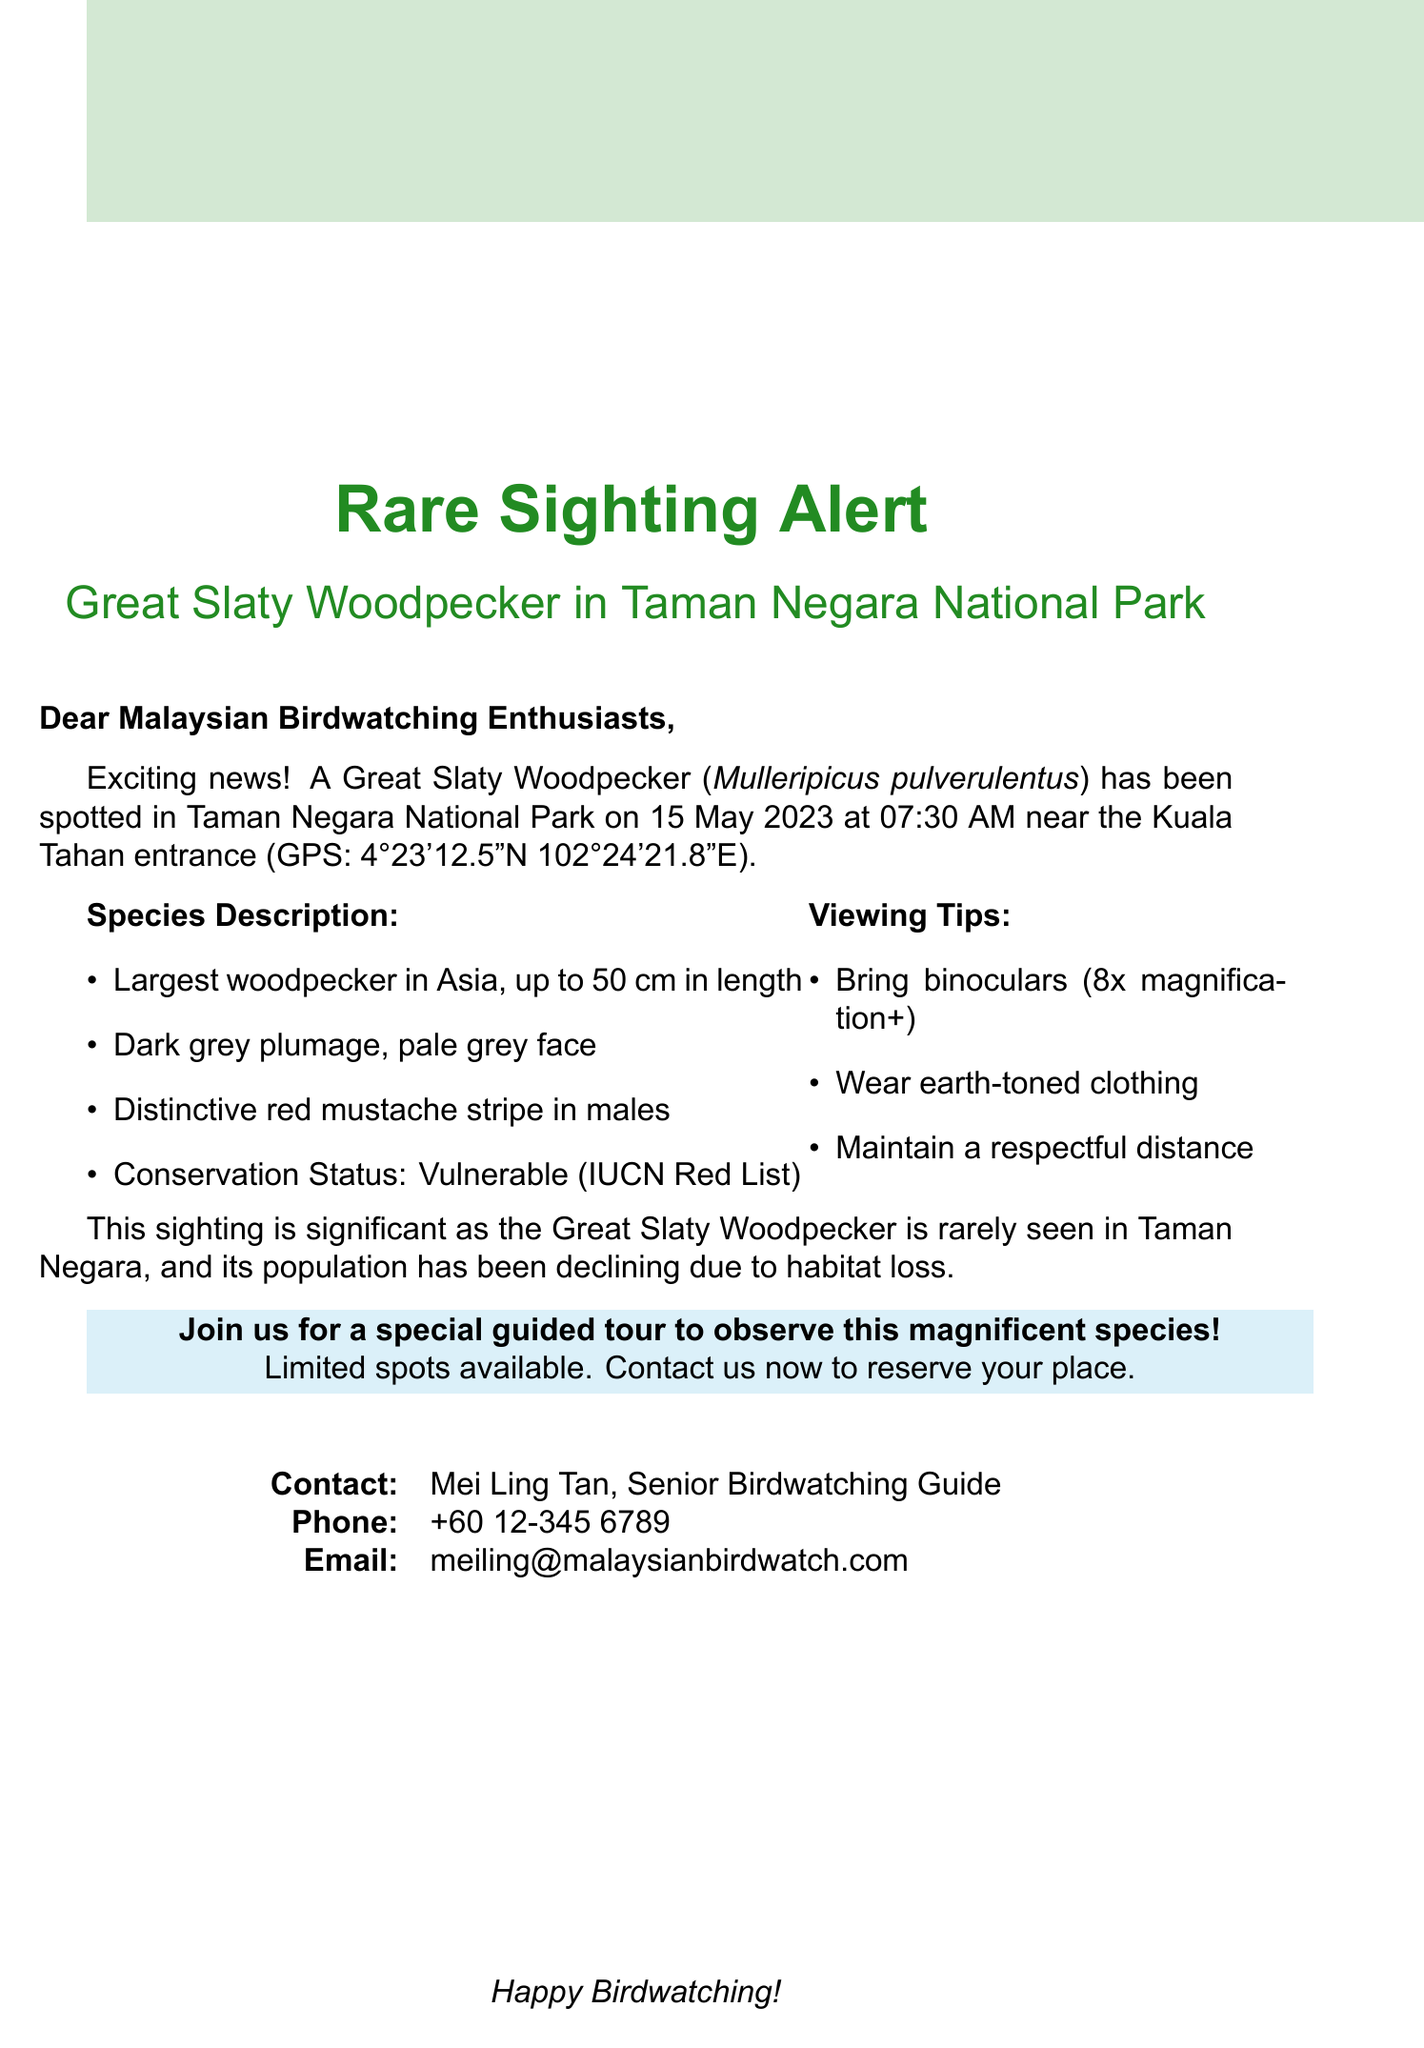What is the common name of the bird? The document provides the common name of the bird, which is Great Slaty Woodpecker.
Answer: Great Slaty Woodpecker What is the scientific name of the Great Slaty Woodpecker? The document lists the scientific name as Mulleripicus pulverulentus.
Answer: Mulleripicus pulverulentus When was the Great Slaty Woodpecker spotted? The sighting date mentioned in the document is 15 May 2023.
Answer: 15 May 2023 What are the GPS coordinates of the sighting? The document specifies the GPS coordinates as 4°23'12.5"N 102°24'21.8"E.
Answer: 4°23'12.5"N 102°24'21.8"E What is the conservation status of the Great Slaty Woodpecker? The document states that the conservation status is Vulnerable according to IUCN Red List.
Answer: Vulnerable What time did the sighting occur? The document indicates that the sighting took place at 07:30 AM.
Answer: 07:30 AM Why is this sighting significant? The document mentions the significance due to the rarity and the declining population of the species.
Answer: Rarely seen; declining population What viewing tips are recommended? The document lists several tips; one notable tip is to bring binoculars with at least 8x magnification.
Answer: Bring binoculars with at least 8x magnification Who should be contacted for more information? The document provides contact information for Mei Ling Tan as the Senior Birdwatching Guide.
Answer: Mei Ling Tan What is the maximum size of the Great Slaty Woodpecker? The document states the size can be up to 50 cm in length.
Answer: Up to 50 cm 